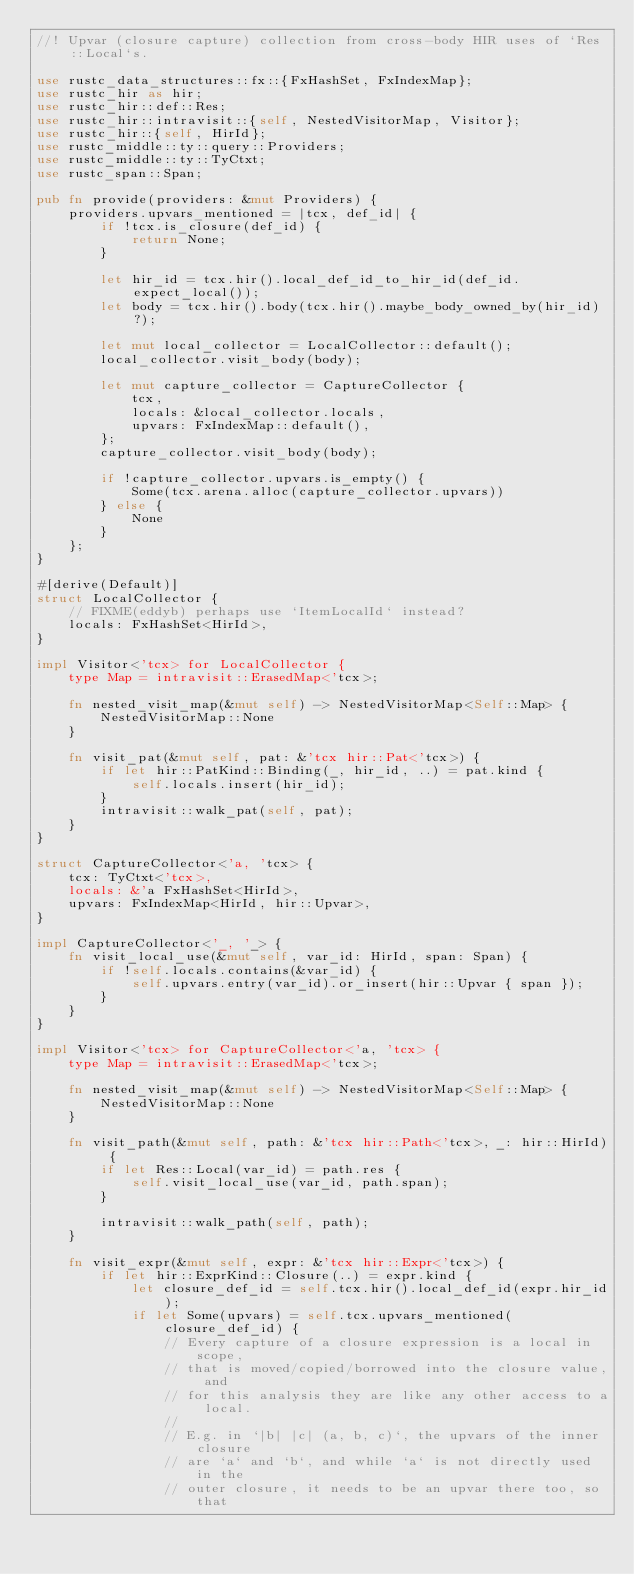Convert code to text. <code><loc_0><loc_0><loc_500><loc_500><_Rust_>//! Upvar (closure capture) collection from cross-body HIR uses of `Res::Local`s.

use rustc_data_structures::fx::{FxHashSet, FxIndexMap};
use rustc_hir as hir;
use rustc_hir::def::Res;
use rustc_hir::intravisit::{self, NestedVisitorMap, Visitor};
use rustc_hir::{self, HirId};
use rustc_middle::ty::query::Providers;
use rustc_middle::ty::TyCtxt;
use rustc_span::Span;

pub fn provide(providers: &mut Providers) {
    providers.upvars_mentioned = |tcx, def_id| {
        if !tcx.is_closure(def_id) {
            return None;
        }

        let hir_id = tcx.hir().local_def_id_to_hir_id(def_id.expect_local());
        let body = tcx.hir().body(tcx.hir().maybe_body_owned_by(hir_id)?);

        let mut local_collector = LocalCollector::default();
        local_collector.visit_body(body);

        let mut capture_collector = CaptureCollector {
            tcx,
            locals: &local_collector.locals,
            upvars: FxIndexMap::default(),
        };
        capture_collector.visit_body(body);

        if !capture_collector.upvars.is_empty() {
            Some(tcx.arena.alloc(capture_collector.upvars))
        } else {
            None
        }
    };
}

#[derive(Default)]
struct LocalCollector {
    // FIXME(eddyb) perhaps use `ItemLocalId` instead?
    locals: FxHashSet<HirId>,
}

impl Visitor<'tcx> for LocalCollector {
    type Map = intravisit::ErasedMap<'tcx>;

    fn nested_visit_map(&mut self) -> NestedVisitorMap<Self::Map> {
        NestedVisitorMap::None
    }

    fn visit_pat(&mut self, pat: &'tcx hir::Pat<'tcx>) {
        if let hir::PatKind::Binding(_, hir_id, ..) = pat.kind {
            self.locals.insert(hir_id);
        }
        intravisit::walk_pat(self, pat);
    }
}

struct CaptureCollector<'a, 'tcx> {
    tcx: TyCtxt<'tcx>,
    locals: &'a FxHashSet<HirId>,
    upvars: FxIndexMap<HirId, hir::Upvar>,
}

impl CaptureCollector<'_, '_> {
    fn visit_local_use(&mut self, var_id: HirId, span: Span) {
        if !self.locals.contains(&var_id) {
            self.upvars.entry(var_id).or_insert(hir::Upvar { span });
        }
    }
}

impl Visitor<'tcx> for CaptureCollector<'a, 'tcx> {
    type Map = intravisit::ErasedMap<'tcx>;

    fn nested_visit_map(&mut self) -> NestedVisitorMap<Self::Map> {
        NestedVisitorMap::None
    }

    fn visit_path(&mut self, path: &'tcx hir::Path<'tcx>, _: hir::HirId) {
        if let Res::Local(var_id) = path.res {
            self.visit_local_use(var_id, path.span);
        }

        intravisit::walk_path(self, path);
    }

    fn visit_expr(&mut self, expr: &'tcx hir::Expr<'tcx>) {
        if let hir::ExprKind::Closure(..) = expr.kind {
            let closure_def_id = self.tcx.hir().local_def_id(expr.hir_id);
            if let Some(upvars) = self.tcx.upvars_mentioned(closure_def_id) {
                // Every capture of a closure expression is a local in scope,
                // that is moved/copied/borrowed into the closure value, and
                // for this analysis they are like any other access to a local.
                //
                // E.g. in `|b| |c| (a, b, c)`, the upvars of the inner closure
                // are `a` and `b`, and while `a` is not directly used in the
                // outer closure, it needs to be an upvar there too, so that</code> 